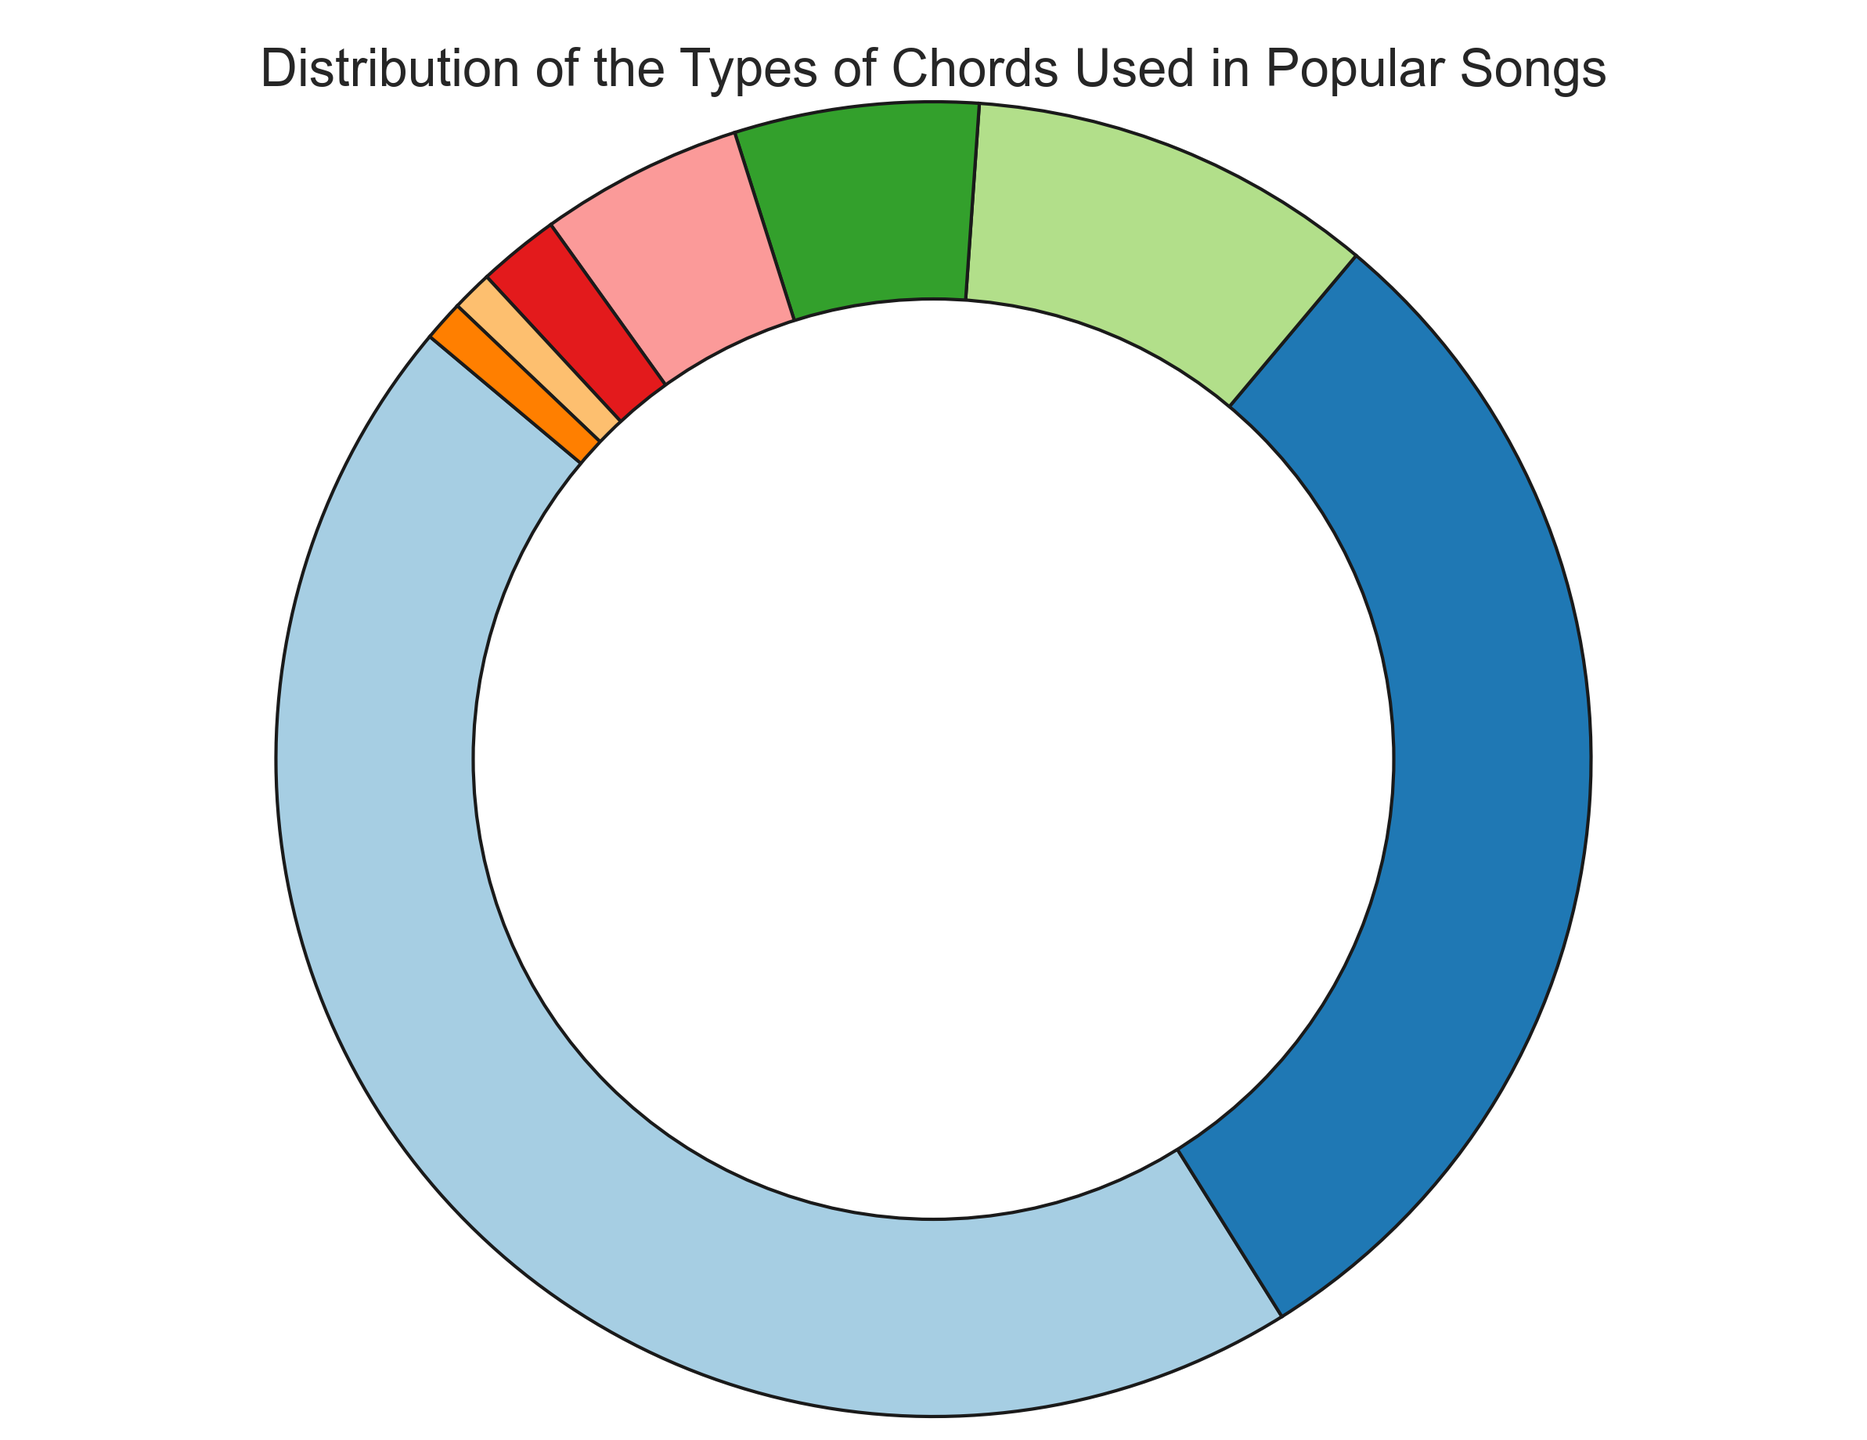What percentage of chords used in popular songs are Major chords? The pie chart shows that Major chords constitute 45% of the chords used in popular songs.
Answer: 45% What is the combined percentage of Minor and Minor 7th chords? According to the pie chart, Minor chords are 30% and Minor 7th chords are 6%. Adding these together, 30% + 6% = 36%.
Answer: 36% Which type of chord is less common, Augmented or Diminished? From the pie chart, Augmented chords account for 1% while Diminished chords account for 2%. Therefore, Augmented chords are less common.
Answer: Augmented What is the most frequently used chord type in popular songs? The pie chart indicates that Major chords have the largest percentage at 45%.
Answer: Major How much more common are Major chords than 7th chords? Major chords make up 45% while 7th chords make up 10%. The difference is 45% - 10% = 35%.
Answer: 35% What is the total percentage of chords that are either 7th, Major 7th, or Minor 7th? The pie chart shows 7th chords at 10%, Major 7th chords at 5%, and Minor 7th chords at 6%. Adding these together, 10% + 5% + 6% = 21%.
Answer: 21% Which chord type makes up the smallest percentage, and what is that percentage? From the pie chart, both Augmented and Suspended chords make up the smallest percentage, each accounting for 1%.
Answer: Augmented and Suspended, 1% Are there more Major chords than the combined total of Diminished, Augmented, and Suspended chords? The pie chart shows that Major chords are 45%. The combined total of Diminished, Augmented, and Suspended chords is 2% + 1% + 1% = 4%. Since 45% is greater than 4%, there are more Major chords.
Answer: Yes What is the percentage difference between Minor 7th and Major 7th chords? Minor 7th chords make up 6% while Major 7th chords make up 5%. The difference is 6% - 5% = 1%.
Answer: 1% 